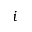<formula> <loc_0><loc_0><loc_500><loc_500>i</formula> 